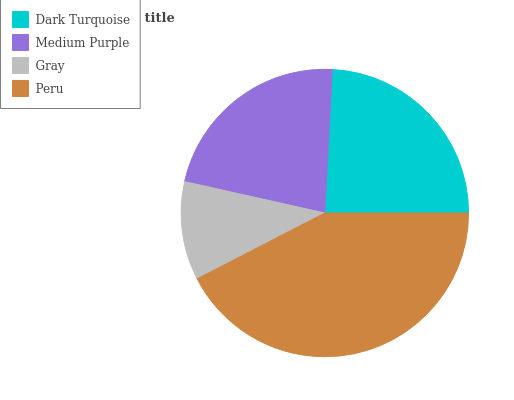Is Gray the minimum?
Answer yes or no. Yes. Is Peru the maximum?
Answer yes or no. Yes. Is Medium Purple the minimum?
Answer yes or no. No. Is Medium Purple the maximum?
Answer yes or no. No. Is Dark Turquoise greater than Medium Purple?
Answer yes or no. Yes. Is Medium Purple less than Dark Turquoise?
Answer yes or no. Yes. Is Medium Purple greater than Dark Turquoise?
Answer yes or no. No. Is Dark Turquoise less than Medium Purple?
Answer yes or no. No. Is Dark Turquoise the high median?
Answer yes or no. Yes. Is Medium Purple the low median?
Answer yes or no. Yes. Is Peru the high median?
Answer yes or no. No. Is Dark Turquoise the low median?
Answer yes or no. No. 